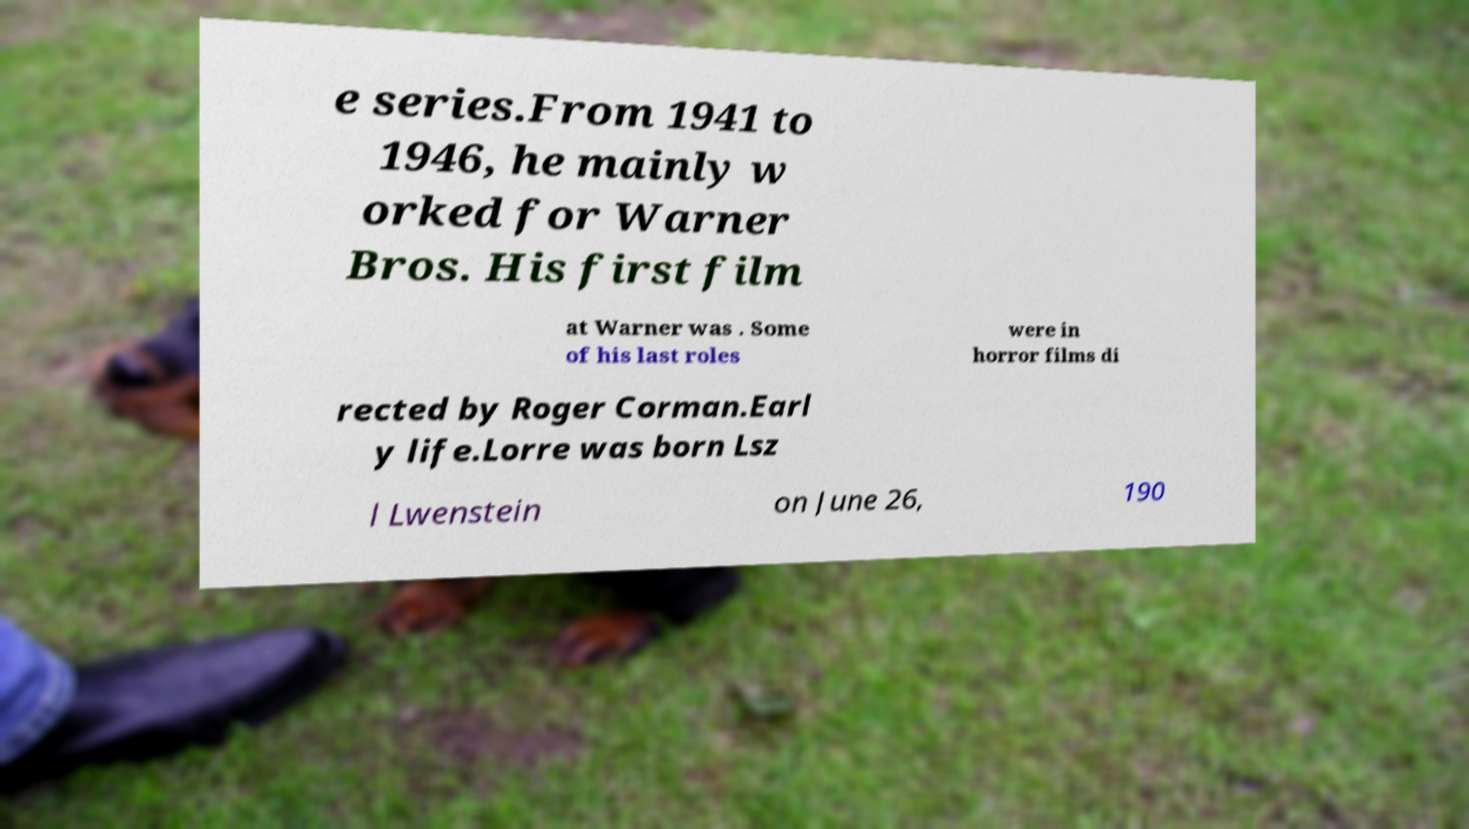What messages or text are displayed in this image? I need them in a readable, typed format. e series.From 1941 to 1946, he mainly w orked for Warner Bros. His first film at Warner was . Some of his last roles were in horror films di rected by Roger Corman.Earl y life.Lorre was born Lsz l Lwenstein on June 26, 190 